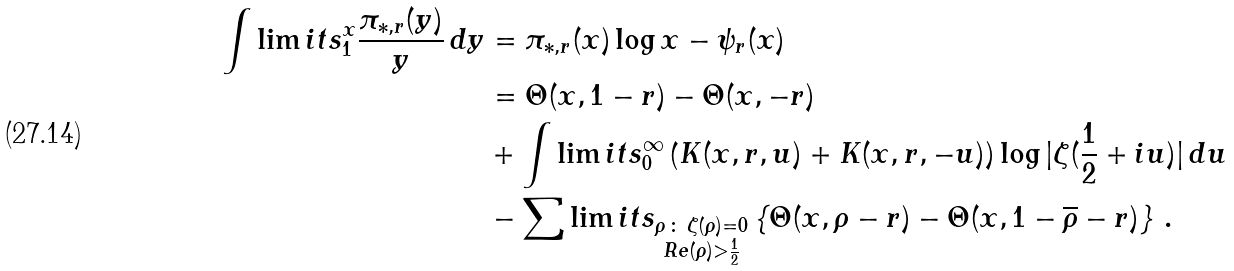Convert formula to latex. <formula><loc_0><loc_0><loc_500><loc_500>\int \lim i t s _ { 1 } ^ { x } \frac { \pi _ { * , r } ( y ) } { y } \, d y & = \pi _ { * , r } ( x ) \log x - \psi _ { r } ( x ) \\ & = \Theta ( x , 1 - r ) - \Theta ( x , - r ) \\ & + \int \lim i t s _ { 0 } ^ { \infty } \left ( K ( x , r , u ) + K ( x , r , - u ) \right ) \log | \zeta ( \frac { 1 } { 2 } + i u ) | \, d u \\ & - \sum \lim i t s _ { \substack { \rho \, \colon \, \zeta ( \rho ) = 0 \\ R e ( \rho ) > \frac { 1 } { 2 } } } \left \{ \Theta ( x , \rho - r ) - \Theta ( x , 1 - \overline { \rho } - r ) \right \} \, .</formula> 